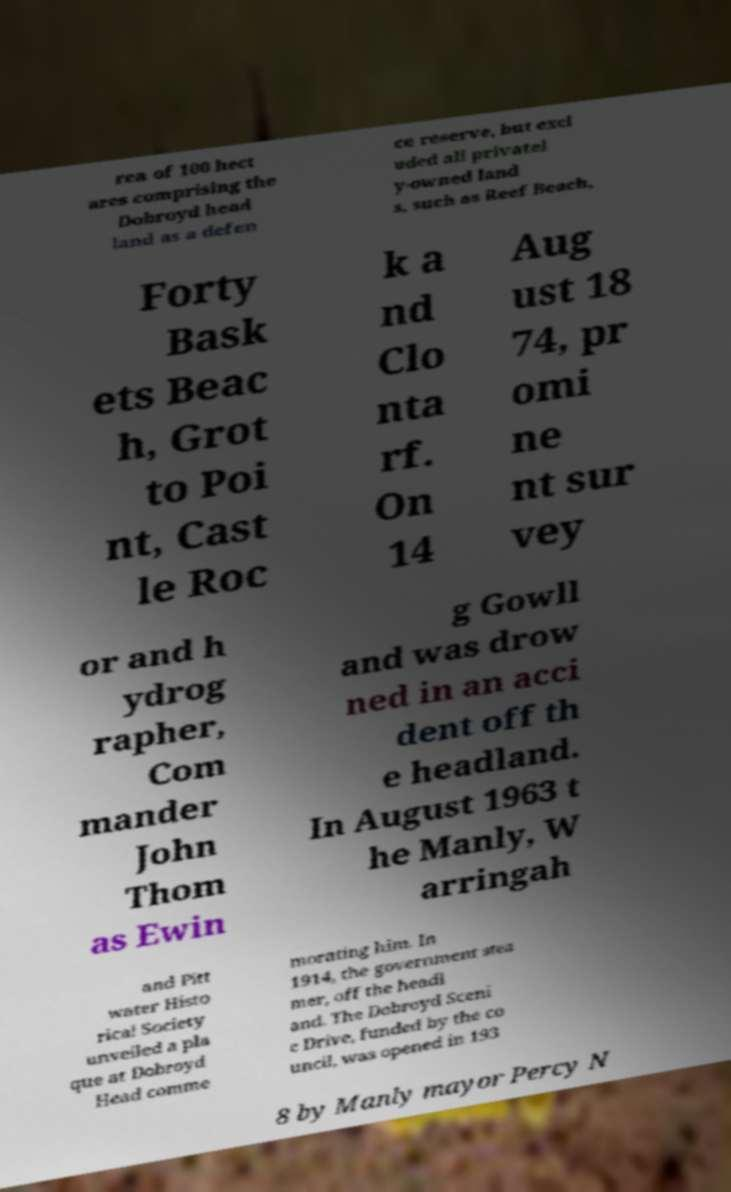Please read and relay the text visible in this image. What does it say? rea of 100 hect ares comprising the Dobroyd head land as a defen ce reserve, but excl uded all privatel y-owned land s, such as Reef Beach, Forty Bask ets Beac h, Grot to Poi nt, Cast le Roc k a nd Clo nta rf. On 14 Aug ust 18 74, pr omi ne nt sur vey or and h ydrog rapher, Com mander John Thom as Ewin g Gowll and was drow ned in an acci dent off th e headland. In August 1963 t he Manly, W arringah and Pitt water Histo rical Society unveiled a pla que at Dobroyd Head comme morating him. In 1914, the government stea mer, off the headl and. The Dobroyd Sceni c Drive, funded by the co uncil, was opened in 193 8 by Manly mayor Percy N 